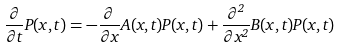Convert formula to latex. <formula><loc_0><loc_0><loc_500><loc_500>\frac { \partial } { \partial t } P ( x , t ) = - \frac { \partial } { \partial x } A ( x , t ) P ( x , t ) + \frac { \partial ^ { 2 } } { \partial x ^ { 2 } } B ( x , t ) P ( x , t )</formula> 